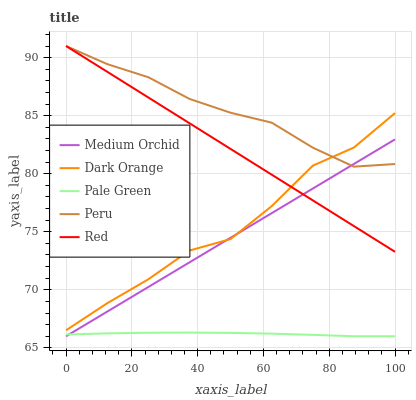Does Pale Green have the minimum area under the curve?
Answer yes or no. Yes. Does Peru have the maximum area under the curve?
Answer yes or no. Yes. Does Medium Orchid have the minimum area under the curve?
Answer yes or no. No. Does Medium Orchid have the maximum area under the curve?
Answer yes or no. No. Is Medium Orchid the smoothest?
Answer yes or no. Yes. Is Dark Orange the roughest?
Answer yes or no. Yes. Is Pale Green the smoothest?
Answer yes or no. No. Is Pale Green the roughest?
Answer yes or no. No. Does Red have the lowest value?
Answer yes or no. No. Does Medium Orchid have the highest value?
Answer yes or no. No. Is Pale Green less than Red?
Answer yes or no. Yes. Is Red greater than Pale Green?
Answer yes or no. Yes. Does Pale Green intersect Red?
Answer yes or no. No. 